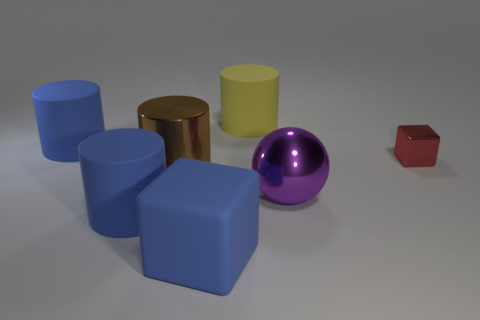Subtract all brown metallic cylinders. How many cylinders are left? 3 Subtract all cubes. How many objects are left? 5 Add 2 blue balls. How many objects exist? 9 Subtract all blue cylinders. How many cylinders are left? 2 Subtract 1 cylinders. How many cylinders are left? 3 Subtract all yellow cylinders. Subtract all green balls. How many cylinders are left? 3 Subtract all brown cylinders. How many blue balls are left? 0 Subtract all purple things. Subtract all large yellow things. How many objects are left? 5 Add 4 red metal blocks. How many red metal blocks are left? 5 Add 7 big brown metallic cylinders. How many big brown metallic cylinders exist? 8 